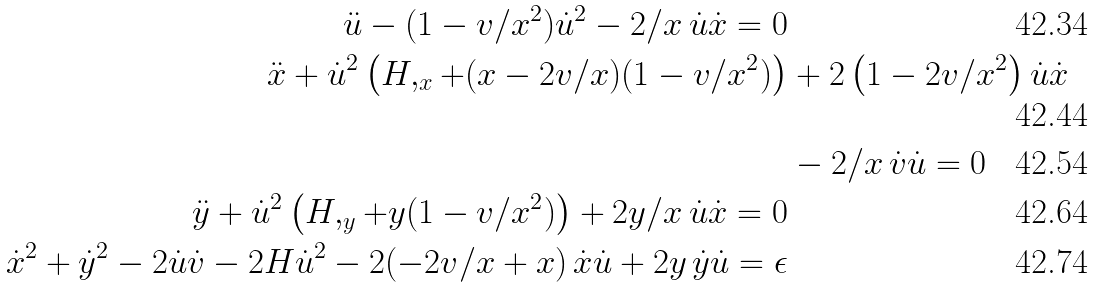<formula> <loc_0><loc_0><loc_500><loc_500>\ddot { u } - ( 1 - v / x ^ { 2 } ) \dot { u } ^ { 2 } - 2 / x \, \dot { u } \dot { x } = 0 \\ \ddot { x } + \dot { u } ^ { 2 } \left ( H , _ { x } + ( x - 2 v / x ) ( 1 - v / x ^ { 2 } ) \right ) & + 2 \left ( 1 - 2 v / x ^ { 2 } \right ) \dot { u } \dot { x } \\ & - 2 / x \, \dot { v } \dot { u } = 0 \\ \ddot { y } + \dot { u } ^ { 2 } \left ( H , _ { y } + y ( 1 - v / x ^ { 2 } ) \right ) + 2 y / x \, \dot { u } \dot { x } = 0 \\ \dot { x } ^ { 2 } + \dot { y } ^ { 2 } - 2 \dot { u } \dot { v } - 2 H \dot { u } ^ { 2 } - 2 ( - 2 v / x + x ) \, \dot { x } \dot { u } + 2 y \, \dot { y } \dot { u } = \epsilon</formula> 